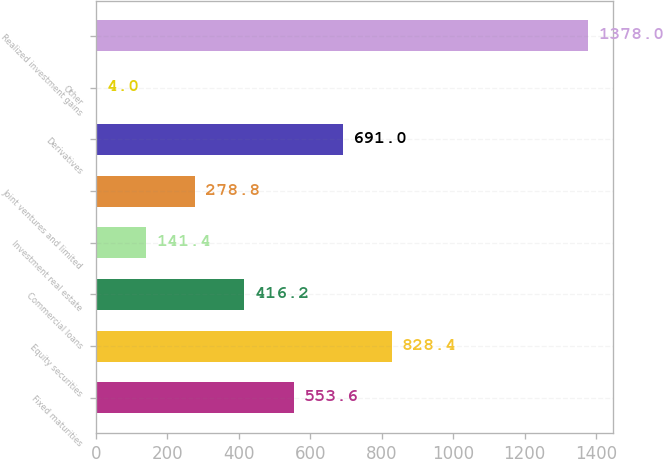Convert chart. <chart><loc_0><loc_0><loc_500><loc_500><bar_chart><fcel>Fixed maturities<fcel>Equity securities<fcel>Commercial loans<fcel>Investment real estate<fcel>Joint ventures and limited<fcel>Derivatives<fcel>Other<fcel>Realized investment gains<nl><fcel>553.6<fcel>828.4<fcel>416.2<fcel>141.4<fcel>278.8<fcel>691<fcel>4<fcel>1378<nl></chart> 